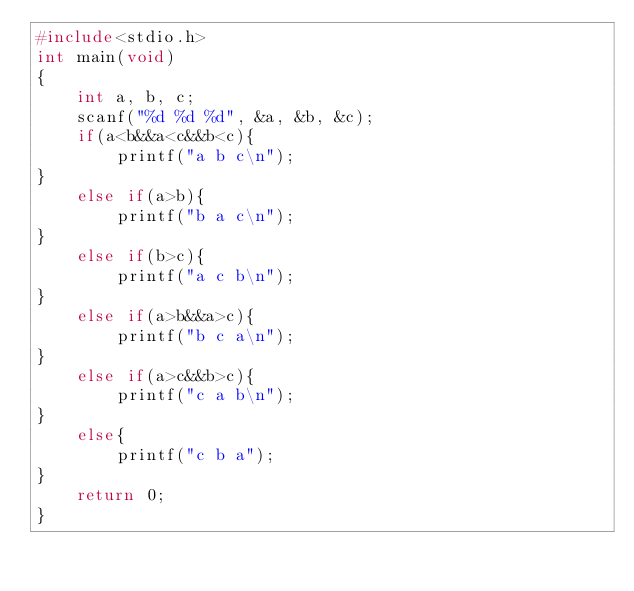<code> <loc_0><loc_0><loc_500><loc_500><_C_>#include<stdio.h>
int main(void)
{
    int a, b, c;
    scanf("%d %d %d", &a, &b, &c);
    if(a<b&&a<c&&b<c){
        printf("a b c\n");
}
    else if(a>b){
        printf("b a c\n");
}
    else if(b>c){
        printf("a c b\n");
}
    else if(a>b&&a>c){
        printf("b c a\n");
}
    else if(a>c&&b>c){
        printf("c a b\n");
}
    else{
        printf("c b a");
}
    return 0;
}

</code> 